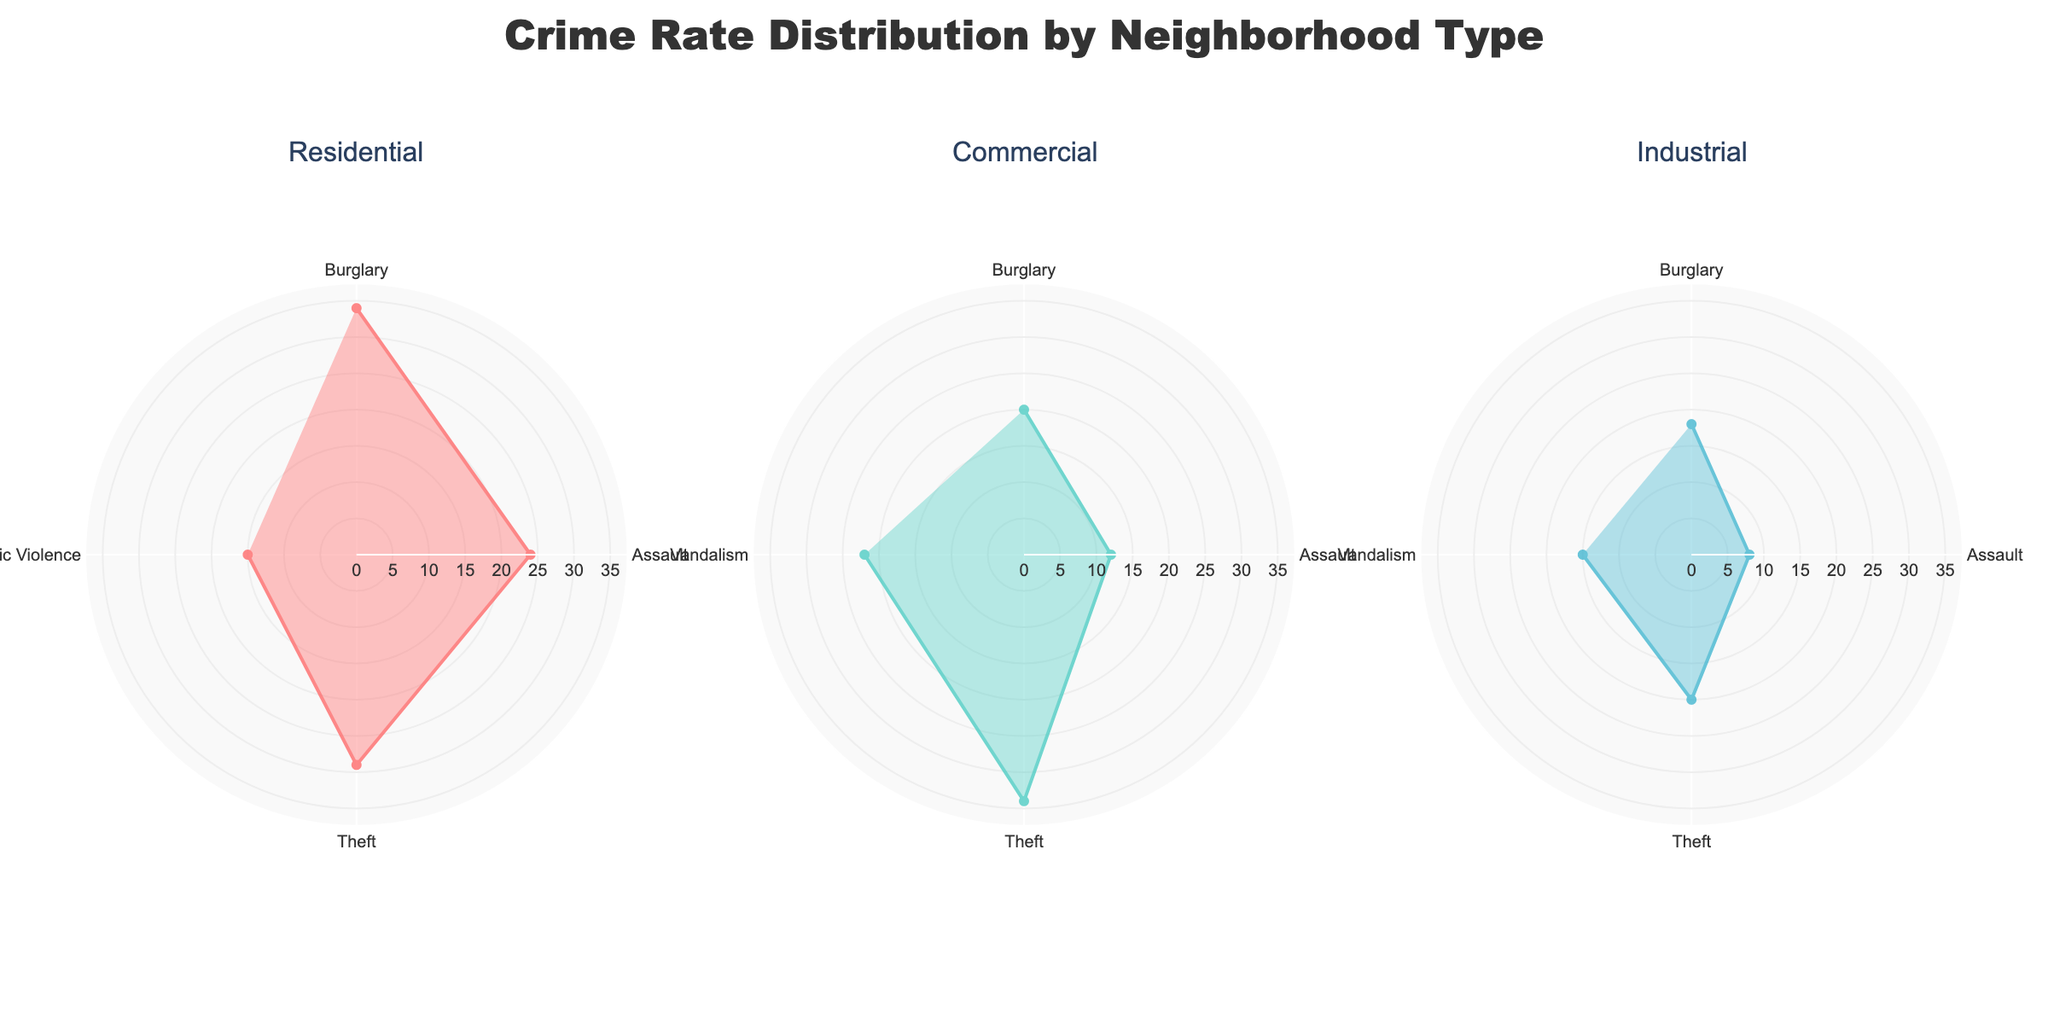Which neighborhood type has the highest incident count for Burglary? By comparing the 'Burglary' segment in each neighborhood type subplot, it's clear that the 'Residential' has the highest value at 34.
Answer: Residential What's the total number of Theft incidents across all neighborhood types? Summing up the 'Theft' incidents from each neighborhood type: Residential (29) + Commercial (34) + Industrial (20) = 83.
Answer: 83 How many crime types are present in each neighborhood type? Each subplot showing the neighborhood types (Residential, Commercial, Industrial) has four crime types, as indicated by four segments.
Answer: 4 Which neighborhood type has the lowest incident count for Assault? By comparing the 'Assault' segment across the subplots, the 'Industrial' neighborhood has the lowest value at 8.
Answer: Industrial Among the crime types in the Commercial neighborhood, which one has the highest count? Looking at the 'Commercial' subplot, 'Theft' has the highest count at 34.
Answer: Theft How does the Domestic Violence incident count in Residential compare to the Vandalism count in Commercial? Comparing the segments, 'Domestic Violence' in Residential has 15 incidents, and 'Vandalism' in Commercial has 22 incidents. 15 is less than 22.
Answer: Domestic Violence has fewer incidents than Vandalism What's the average incident count for all crime types in the Industrial neighborhood? Summing the counts in Industrial (Burglary 18, Assault 8, Theft 20, Vandalism 15) gives 61. Dividing by 4 crime types, the average is 15.25.
Answer: 15.25 What is the combined incident count for Burglary across all neighborhood types? Adding the Burglary incidents: Residential (34) + Commercial (20) + Industrial (18) = 72.
Answer: 72 Which crime type in Residential has the second highest incident count? In the Residential subplot, 'Theft' has 29 incidents, second to 'Burglary' with 34.
Answer: Theft 